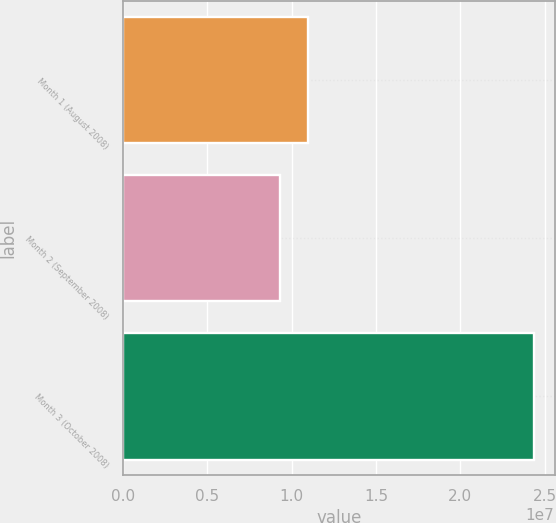Convert chart to OTSL. <chart><loc_0><loc_0><loc_500><loc_500><bar_chart><fcel>Month 1 (August 2008)<fcel>Month 2 (September 2008)<fcel>Month 3 (October 2008)<nl><fcel>1.09787e+07<fcel>9.32647e+06<fcel>2.43709e+07<nl></chart> 